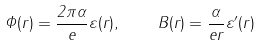Convert formula to latex. <formula><loc_0><loc_0><loc_500><loc_500>\Phi ( r ) = \frac { 2 \pi \alpha } { e } \varepsilon ( r ) , \quad B ( r ) = \frac { \alpha } { e r } \varepsilon ^ { \prime } ( r )</formula> 